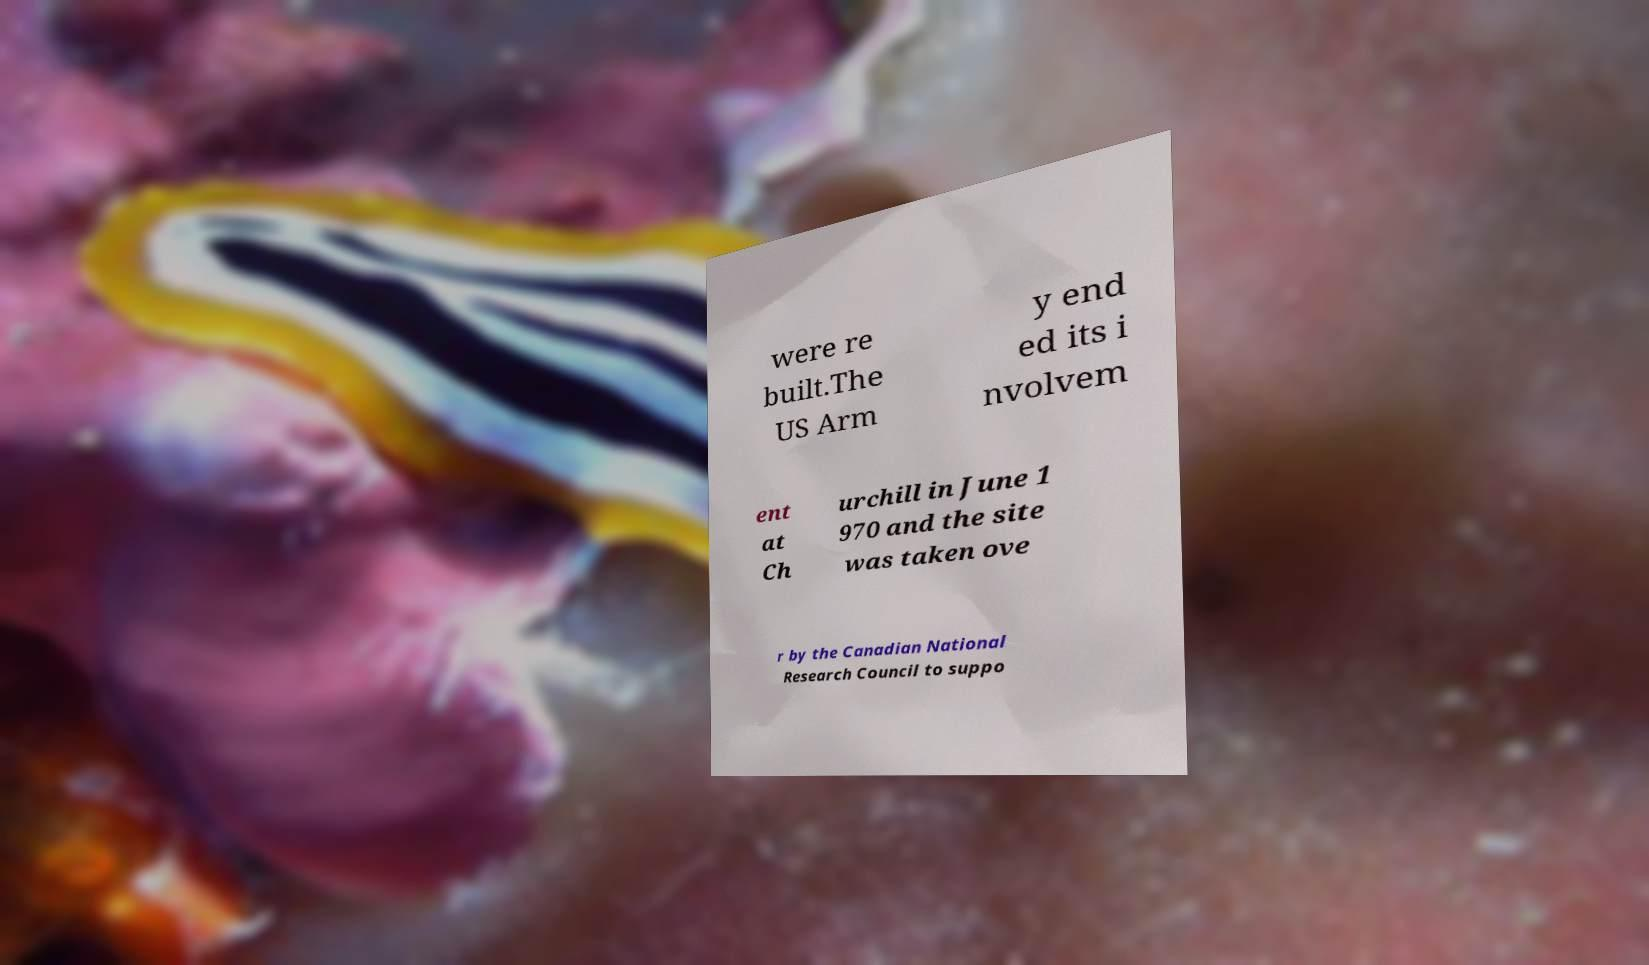Please identify and transcribe the text found in this image. were re built.The US Arm y end ed its i nvolvem ent at Ch urchill in June 1 970 and the site was taken ove r by the Canadian National Research Council to suppo 